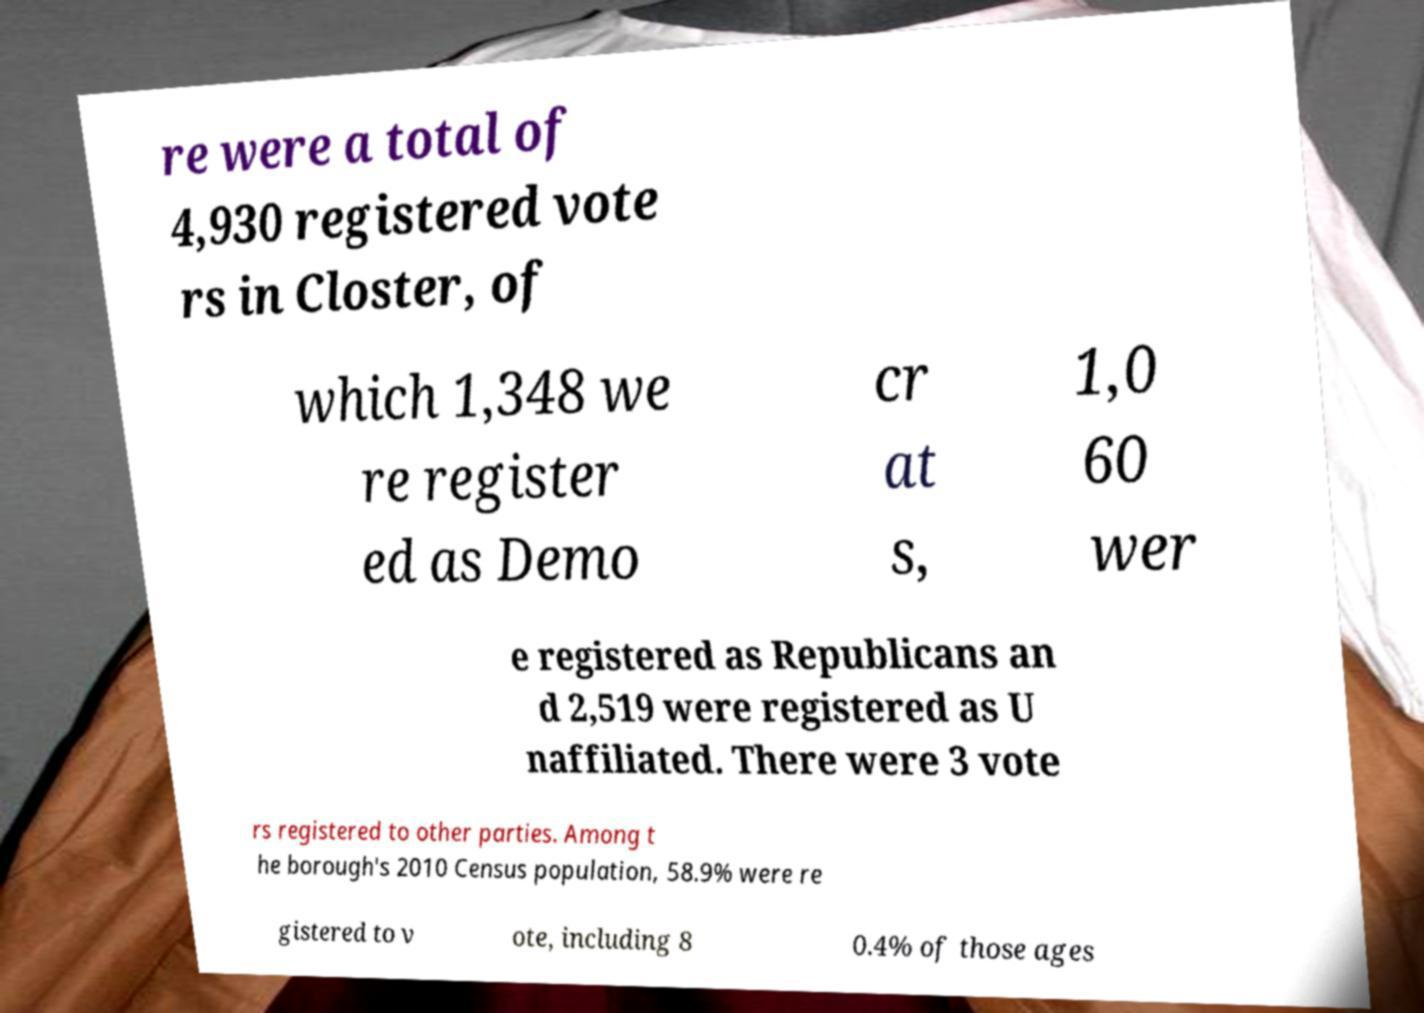Could you extract and type out the text from this image? re were a total of 4,930 registered vote rs in Closter, of which 1,348 we re register ed as Demo cr at s, 1,0 60 wer e registered as Republicans an d 2,519 were registered as U naffiliated. There were 3 vote rs registered to other parties. Among t he borough's 2010 Census population, 58.9% were re gistered to v ote, including 8 0.4% of those ages 